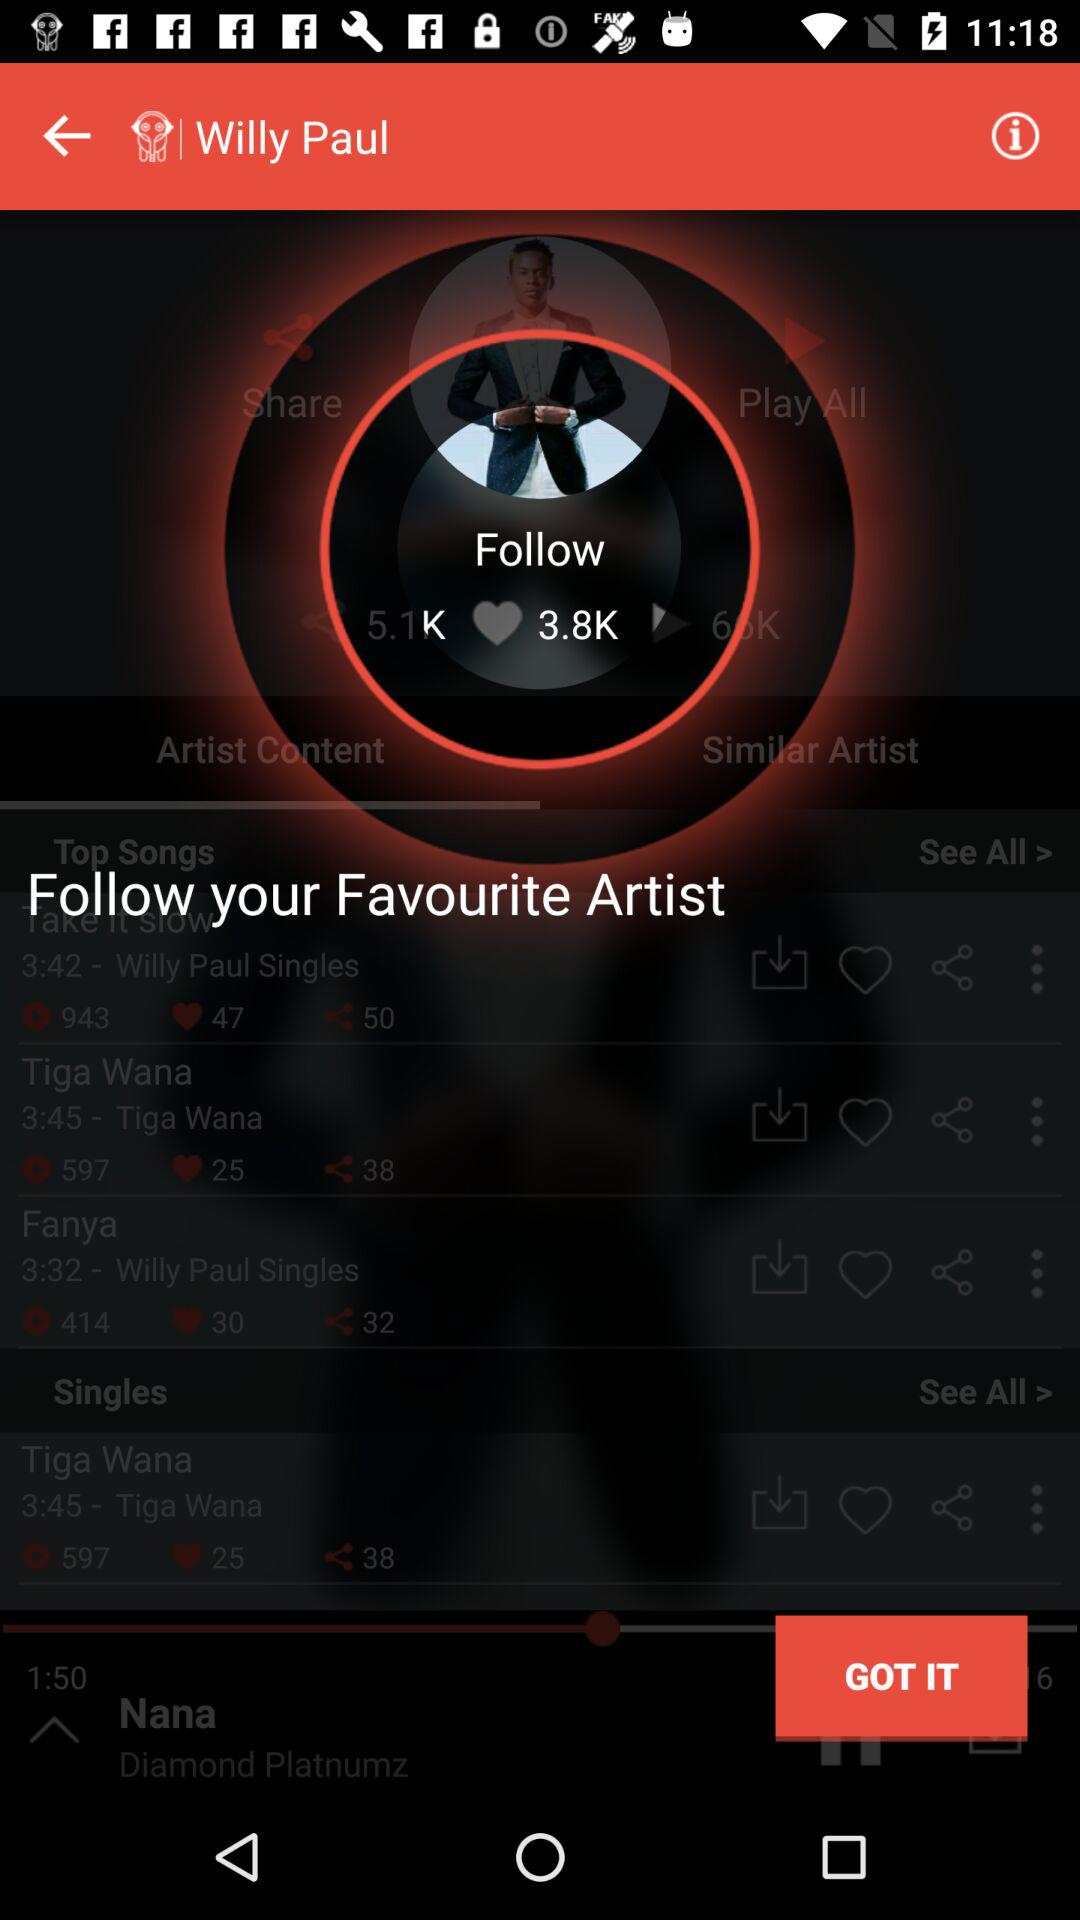What is the duration of the song "Tiga Wana"? The duration of the song "Tiga Wana" is 3 minutes 45 seconds. 